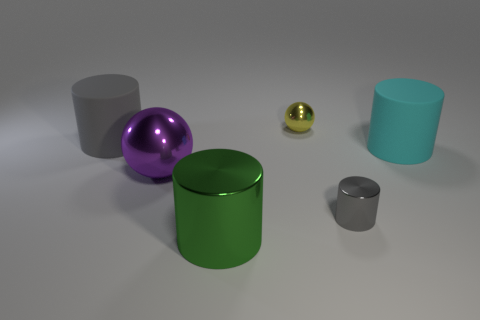Subtract all blue cubes. How many purple spheres are left? 1 Subtract all purple things. Subtract all blue matte things. How many objects are left? 5 Add 4 purple metallic spheres. How many purple metallic spheres are left? 5 Add 2 tiny green matte balls. How many tiny green matte balls exist? 2 Add 2 red rubber balls. How many objects exist? 8 Subtract all purple spheres. How many spheres are left? 1 Subtract all big cyan rubber cylinders. How many cylinders are left? 3 Subtract 1 purple spheres. How many objects are left? 5 Subtract all cylinders. How many objects are left? 2 Subtract 3 cylinders. How many cylinders are left? 1 